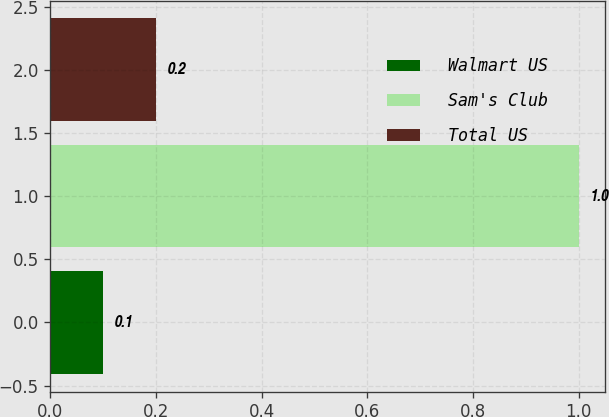Convert chart to OTSL. <chart><loc_0><loc_0><loc_500><loc_500><bar_chart><fcel>Walmart US<fcel>Sam's Club<fcel>Total US<nl><fcel>0.1<fcel>1<fcel>0.2<nl></chart> 